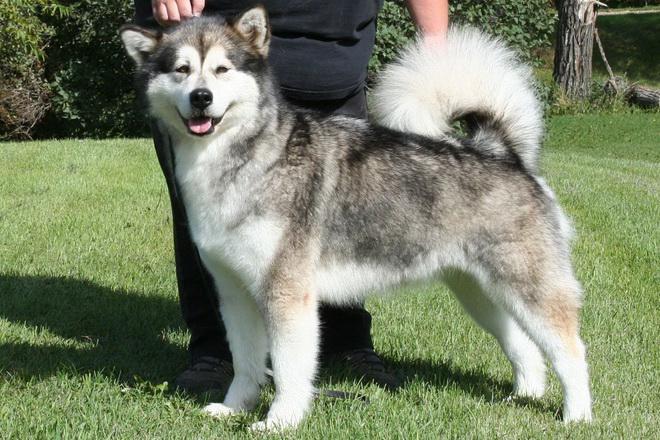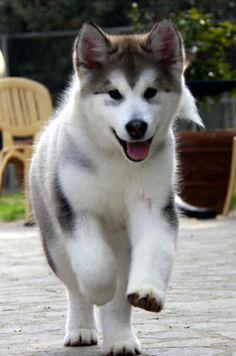The first image is the image on the left, the second image is the image on the right. For the images shown, is this caption "There are exactly two dogs with their mouths open." true? Answer yes or no. Yes. 